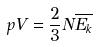Convert formula to latex. <formula><loc_0><loc_0><loc_500><loc_500>p V = \frac { 2 } { 3 } N \overline { E _ { k } }</formula> 